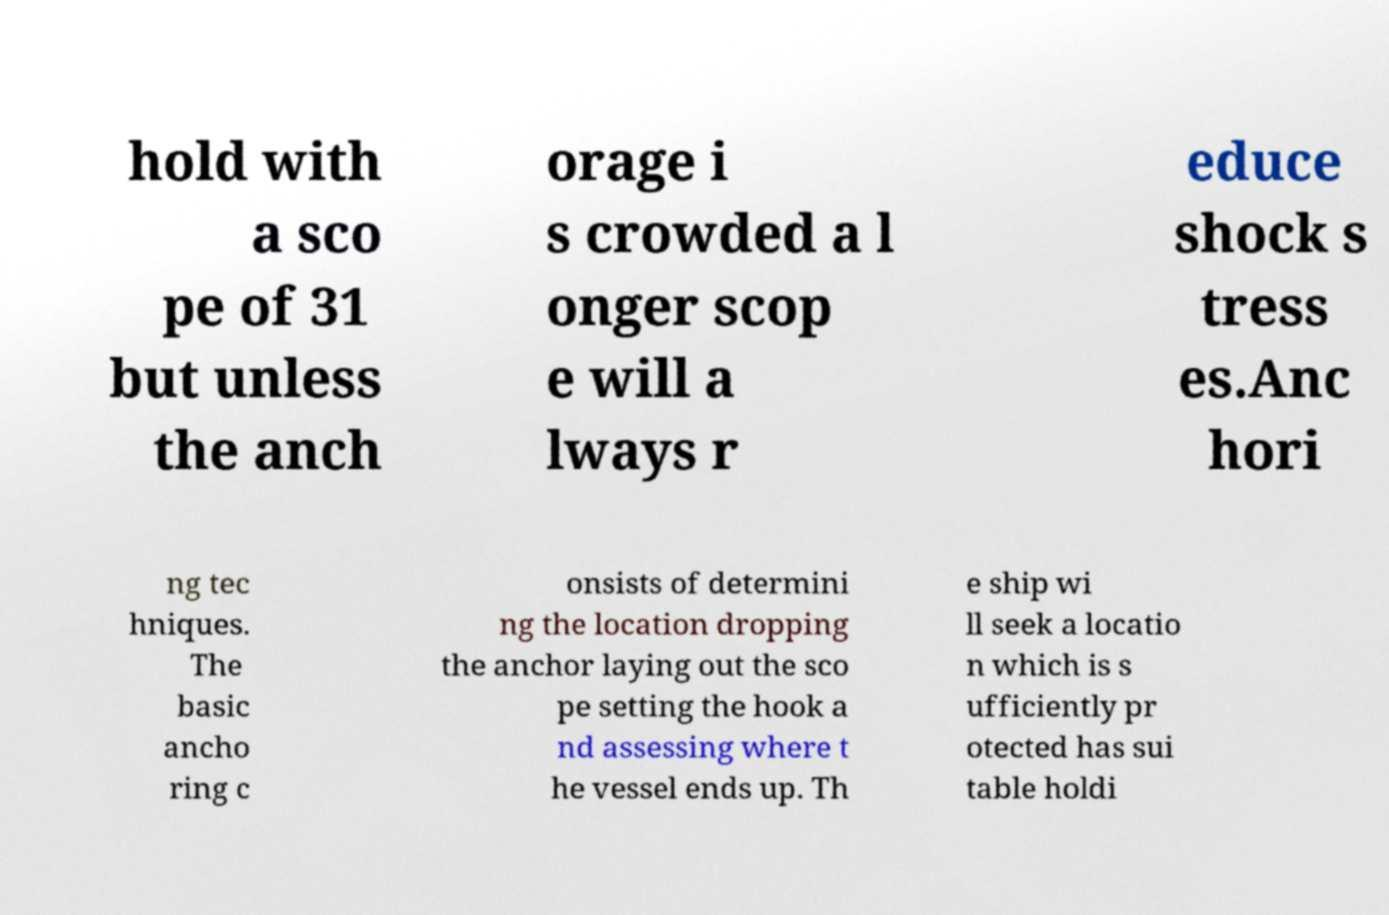Please identify and transcribe the text found in this image. hold with a sco pe of 31 but unless the anch orage i s crowded a l onger scop e will a lways r educe shock s tress es.Anc hori ng tec hniques. The basic ancho ring c onsists of determini ng the location dropping the anchor laying out the sco pe setting the hook a nd assessing where t he vessel ends up. Th e ship wi ll seek a locatio n which is s ufficiently pr otected has sui table holdi 